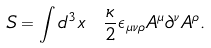<formula> <loc_0><loc_0><loc_500><loc_500>S = \int d ^ { 3 } x \ \frac { \kappa } { 2 } \epsilon _ { \mu \nu \rho } A ^ { \mu } \partial ^ { \nu } A ^ { \rho } .</formula> 